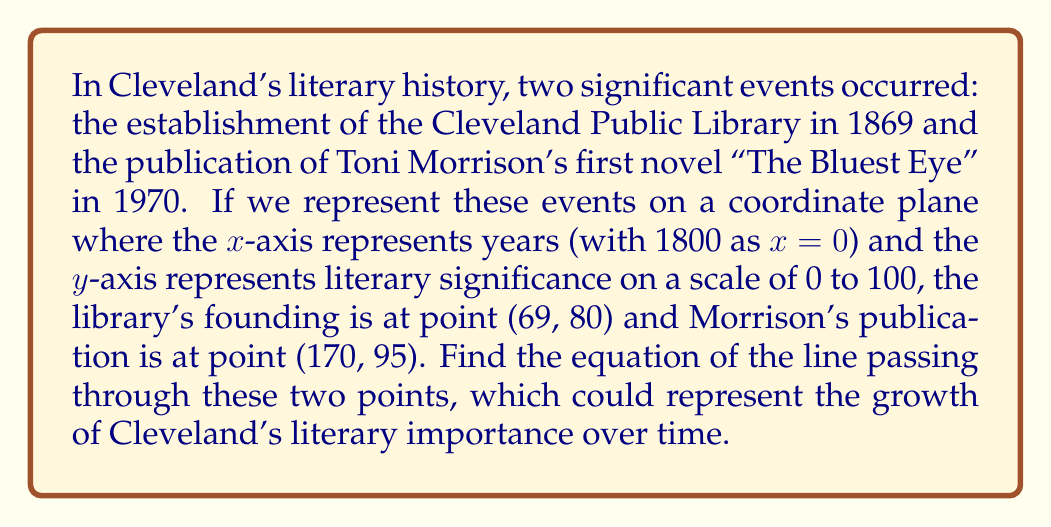Teach me how to tackle this problem. To find the equation of a line passing through two points, we can use the point-slope form of a line: $y - y_1 = m(x - x_1)$, where $m$ is the slope of the line.

Step 1: Calculate the slope $m$ using the formula:
$m = \frac{y_2 - y_1}{x_2 - x_1}$

Where $(x_1, y_1) = (69, 80)$ and $(x_2, y_2) = (170, 95)$

$m = \frac{95 - 80}{170 - 69} = \frac{15}{101} \approx 0.1485$

Step 2: Use either point and the calculated slope in the point-slope form. Let's use $(69, 80)$:

$y - 80 = \frac{15}{101}(x - 69)$

Step 3: Simplify and rearrange to slope-intercept form $y = mx + b$:

$y = \frac{15}{101}x - \frac{15}{101}(69) + 80$

$y = \frac{15}{101}x - \frac{1035}{101} + \frac{8080}{101}$

$y = \frac{15}{101}x + \frac{7045}{101}$

This is the equation of the line in slope-intercept form.
Answer: $y = \frac{15}{101}x + \frac{7045}{101}$ 